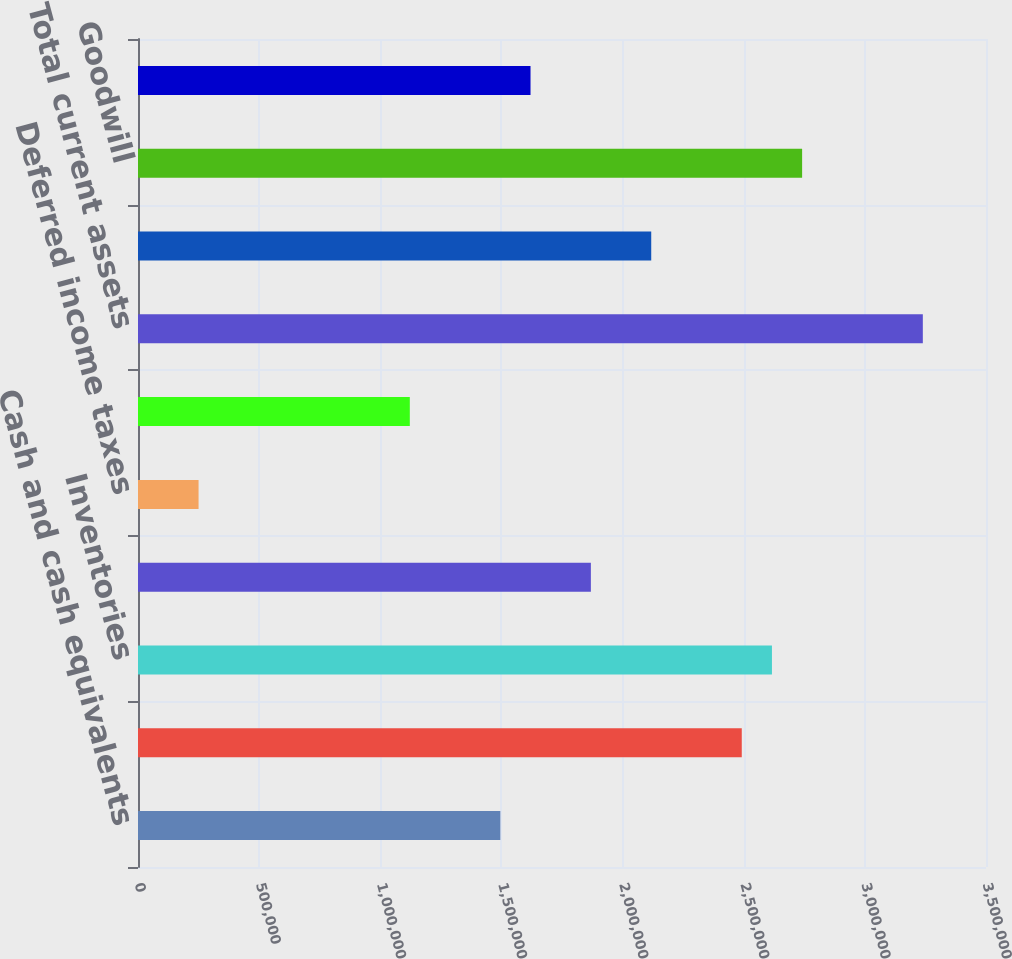<chart> <loc_0><loc_0><loc_500><loc_500><bar_chart><fcel>Cash and cash equivalents<fcel>Receivables net<fcel>Inventories<fcel>Costs in excess of billings<fcel>Deferred income taxes<fcel>Prepaid and other current<fcel>Total current assets<fcel>Property plant and equipment<fcel>Goodwill<fcel>Intangibles net<nl><fcel>1.49551e+06<fcel>2.49195e+06<fcel>2.6165e+06<fcel>1.86917e+06<fcel>249961<fcel>1.12185e+06<fcel>3.23928e+06<fcel>2.11828e+06<fcel>2.74106e+06<fcel>1.62006e+06<nl></chart> 